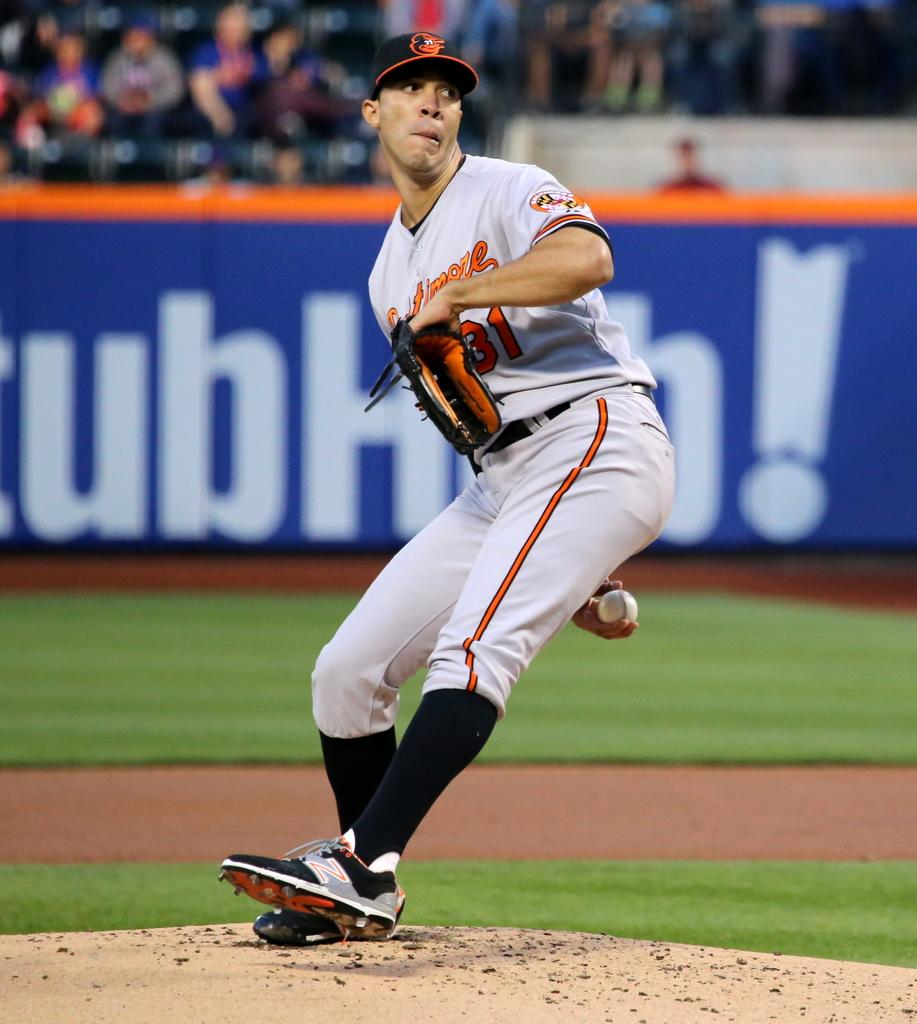<image>
Describe the image concisely. A man throwing a baseball with the number 31 on his shirt. 